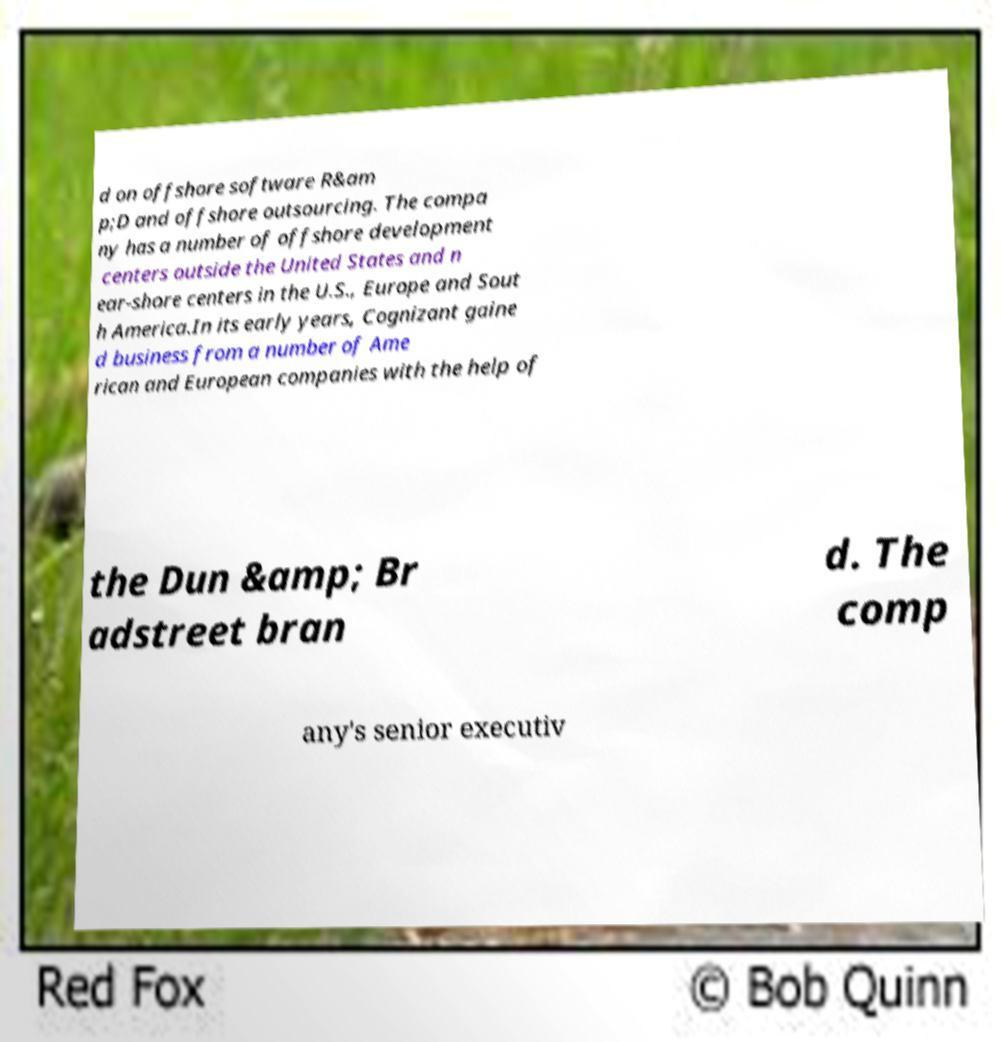Can you read and provide the text displayed in the image?This photo seems to have some interesting text. Can you extract and type it out for me? d on offshore software R&am p;D and offshore outsourcing. The compa ny has a number of offshore development centers outside the United States and n ear-shore centers in the U.S., Europe and Sout h America.In its early years, Cognizant gaine d business from a number of Ame rican and European companies with the help of the Dun &amp; Br adstreet bran d. The comp any's senior executiv 